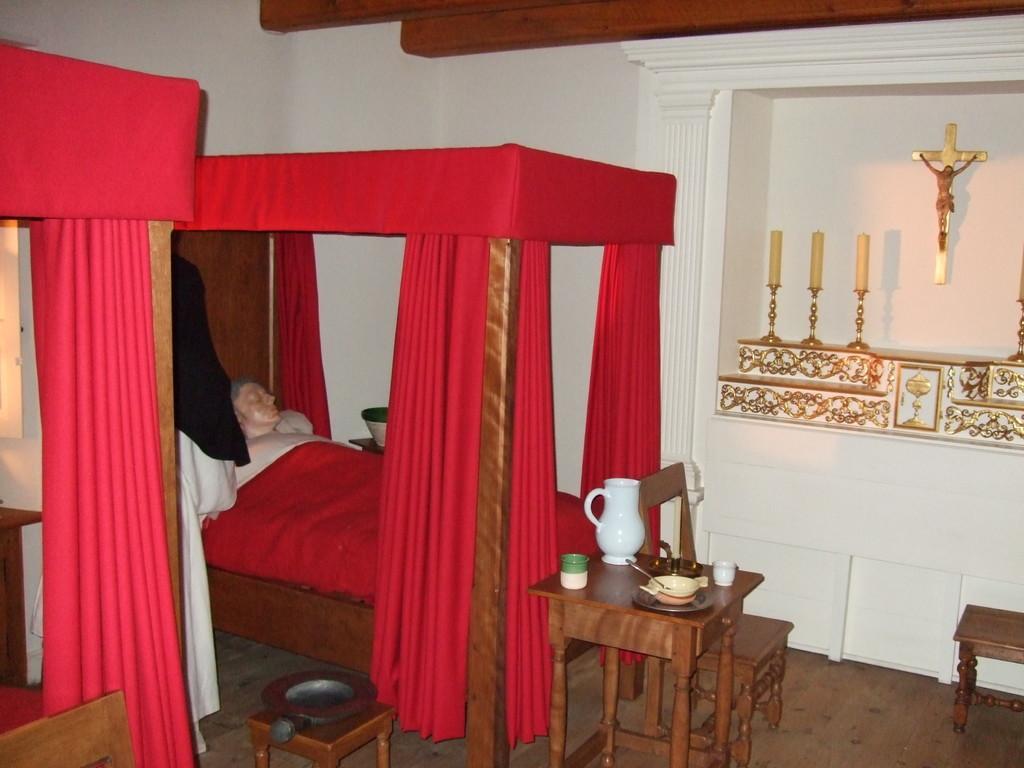In one or two sentences, can you explain what this image depicts? In a given image I can see a bed, person, table, chairs, curtains and I can also see some objects on the table. 